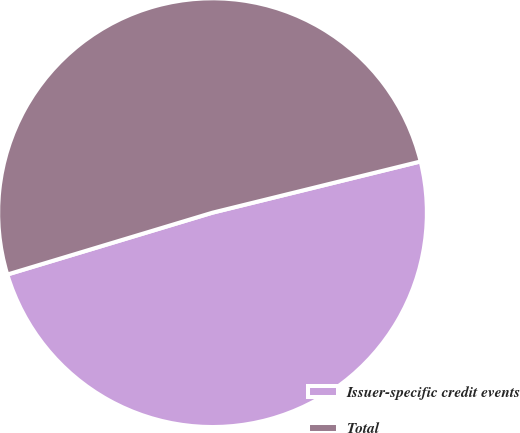Convert chart to OTSL. <chart><loc_0><loc_0><loc_500><loc_500><pie_chart><fcel>Issuer-specific credit events<fcel>Total<nl><fcel>49.18%<fcel>50.82%<nl></chart> 